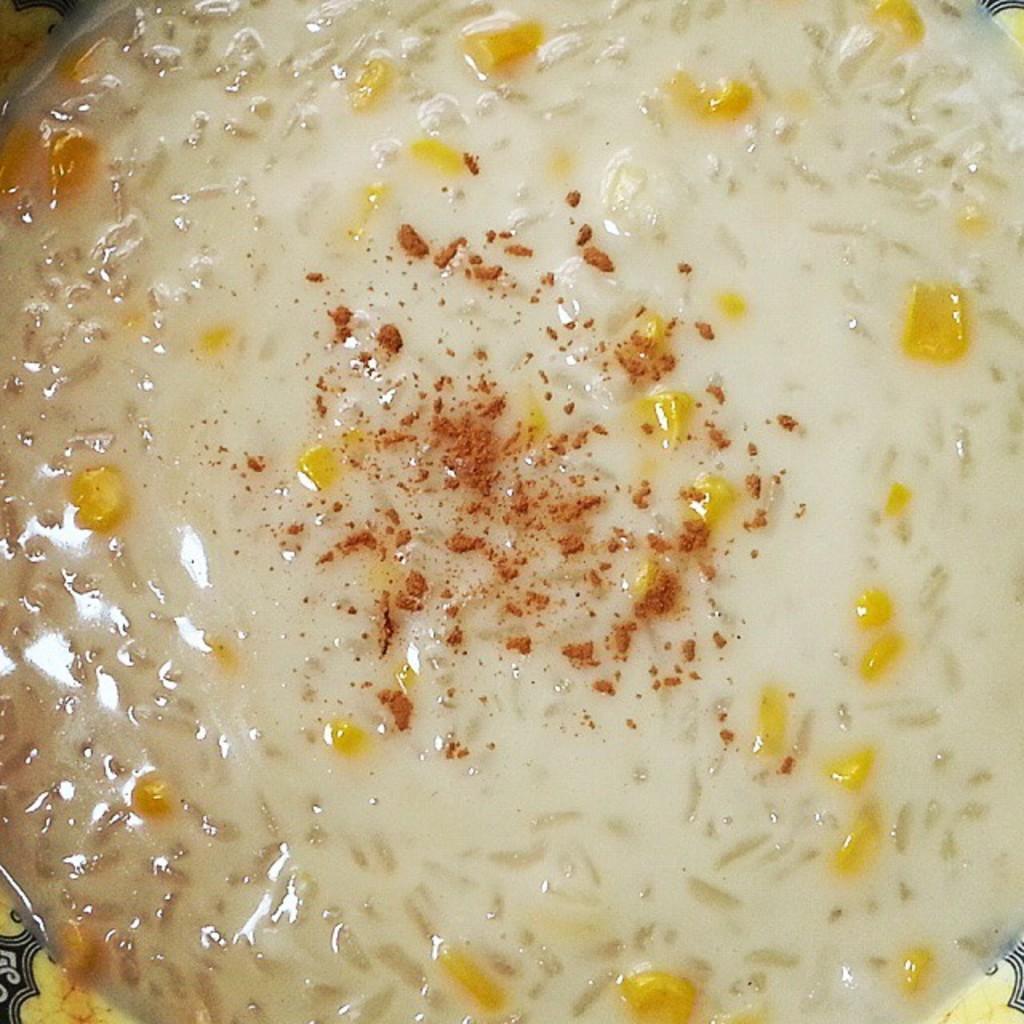How would you summarize this image in a sentence or two? In this image, we can see some food item in an object. 